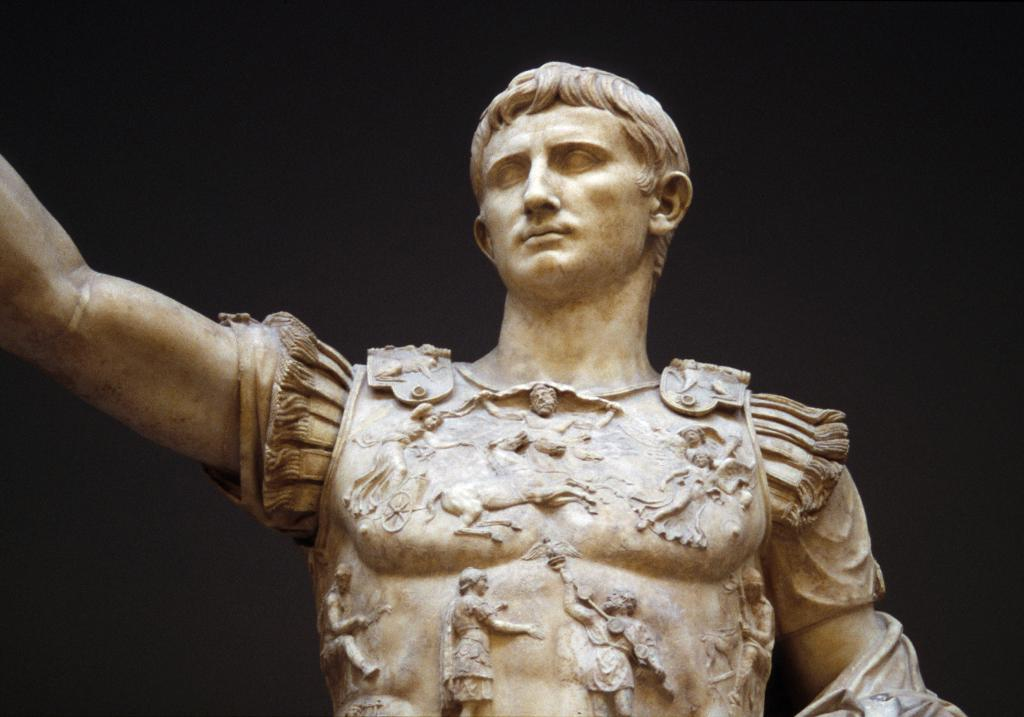What is the main subject in the image? There is a statue in the image. What can be seen in the background of the image? The background of the image is black. How does the statue use force to open the door in the image? There is no door present in the image, and therefore no such activity can be observed. 